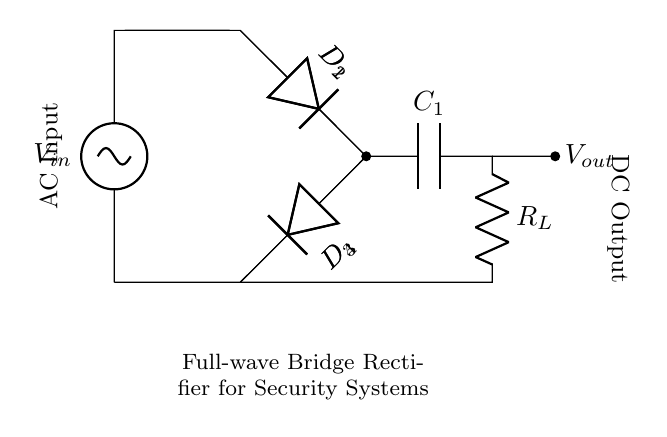What type of circuit is shown? The circuit is a full-wave bridge rectifier, which is characterized by its use of four diodes arranged in a bridge configuration to convert AC voltage to DC voltage.
Answer: full-wave bridge rectifier How many diodes are used in this circuit? The diagram shows four diodes labeled D1, D2, D3, and D4, which are necessary for the bridge rectifier arrangement to allow current flow during both halves of the AC cycle.
Answer: four diodes What is the role of the capacitor in this circuit? The capacitor, denoted as C1, serves to smooth the output voltage by storing charge and releasing it to maintain a more constant voltage level at the output, which is essential in providing stable DC to sensitive devices.
Answer: smoothing What is the purpose of the load resistor in the circuit? The load resistor R_L is used to emulate a connected device's resistance, allowing the circuit to deliver power to the load while simultaneously providing a measurable output voltage across the resistor for analysis.
Answer: power delivery What is the output type of this circuit? The circuit converts AC input voltage into a pulsating DC output voltage, which is indicated by the directionality of current flow and the use of diodes that allow current in one direction.
Answer: pulsating DC How does the full-wave bridge rectifier improve efficiency compared to a half-wave rectifier? The full-wave bridge rectifier uses both halves of the AC input signal, which effectively doubles the output frequency and provides a steadier and more usable DC output, whereas a half-wave rectifier only utilizes one half of the AC cycle.
Answer: more efficient 